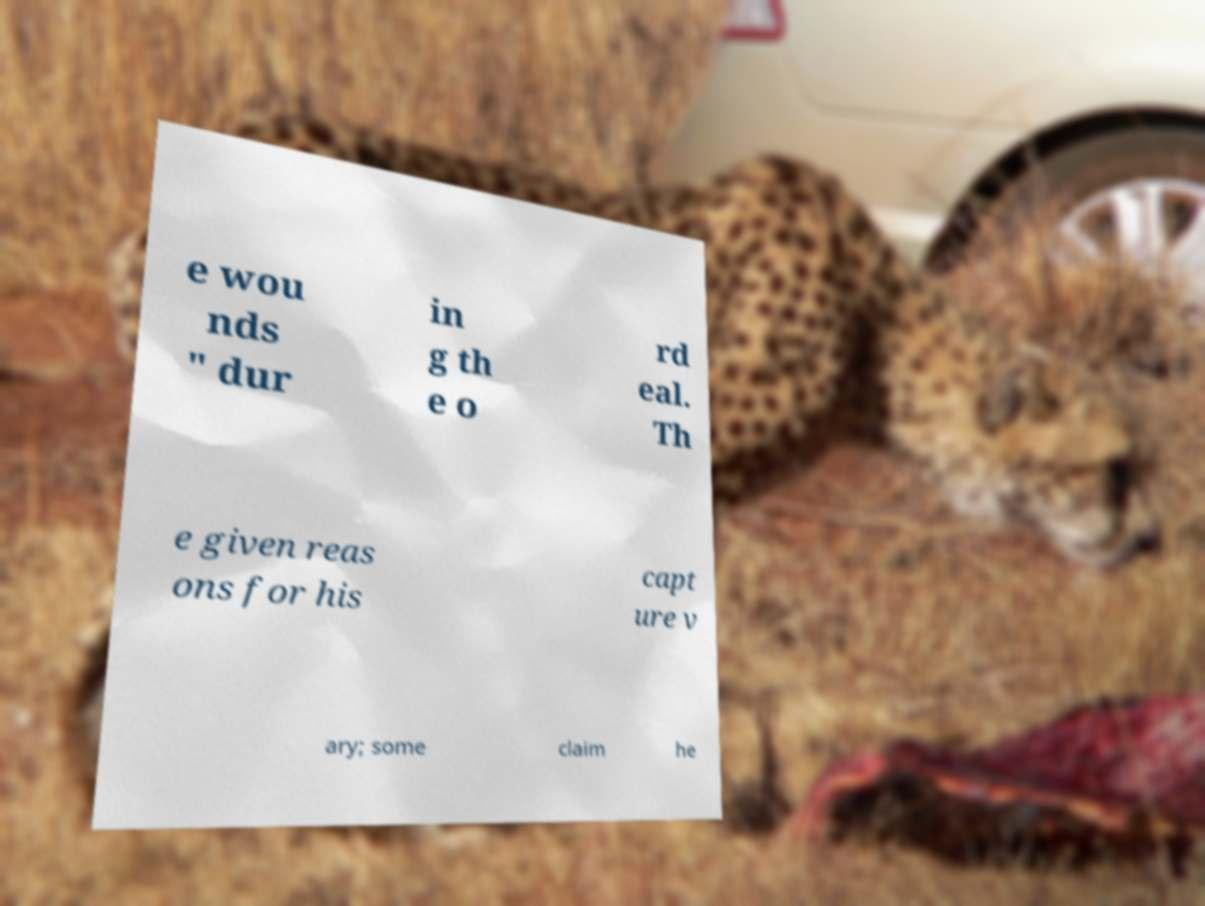What messages or text are displayed in this image? I need them in a readable, typed format. e wou nds " dur in g th e o rd eal. Th e given reas ons for his capt ure v ary; some claim he 